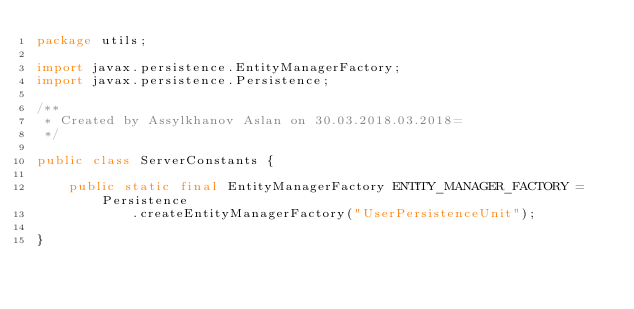<code> <loc_0><loc_0><loc_500><loc_500><_Java_>package utils;

import javax.persistence.EntityManagerFactory;
import javax.persistence.Persistence;

/**
 * Created by Assylkhanov Aslan on 30.03.2018.03.2018=
 */

public class ServerConstants {

    public static final EntityManagerFactory ENTITY_MANAGER_FACTORY = Persistence
            .createEntityManagerFactory("UserPersistenceUnit");

}
</code> 